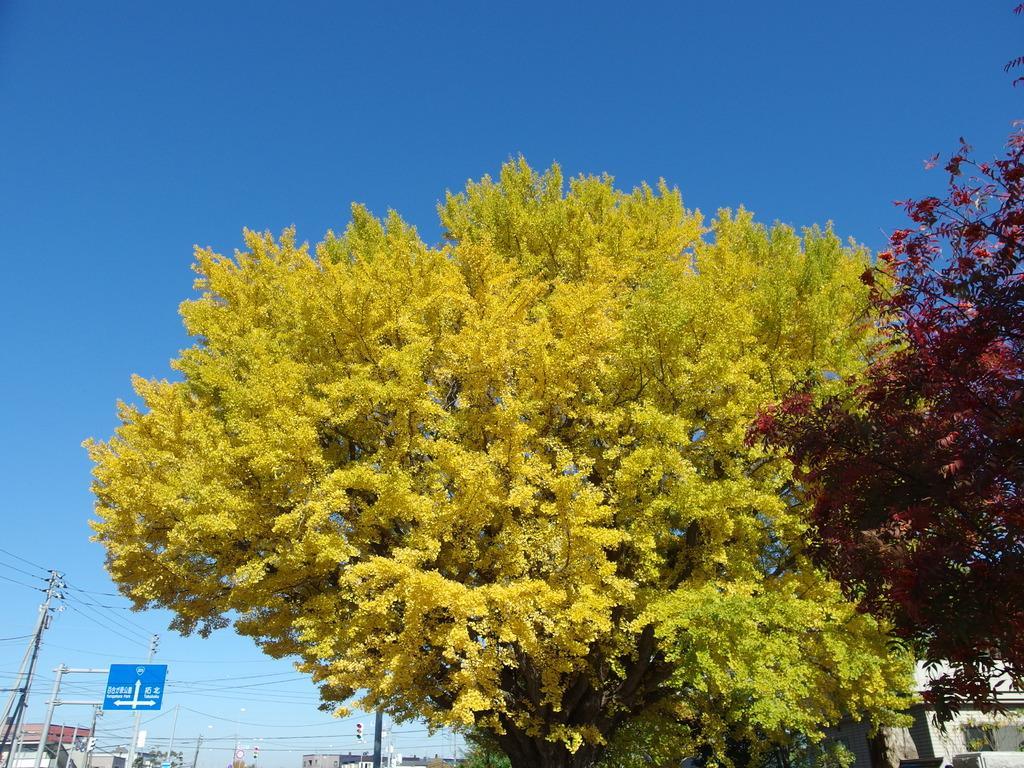Describe this image in one or two sentences. In this picture I can see trees, buildings and few poles and a sign board to the pole and a blue sky. 